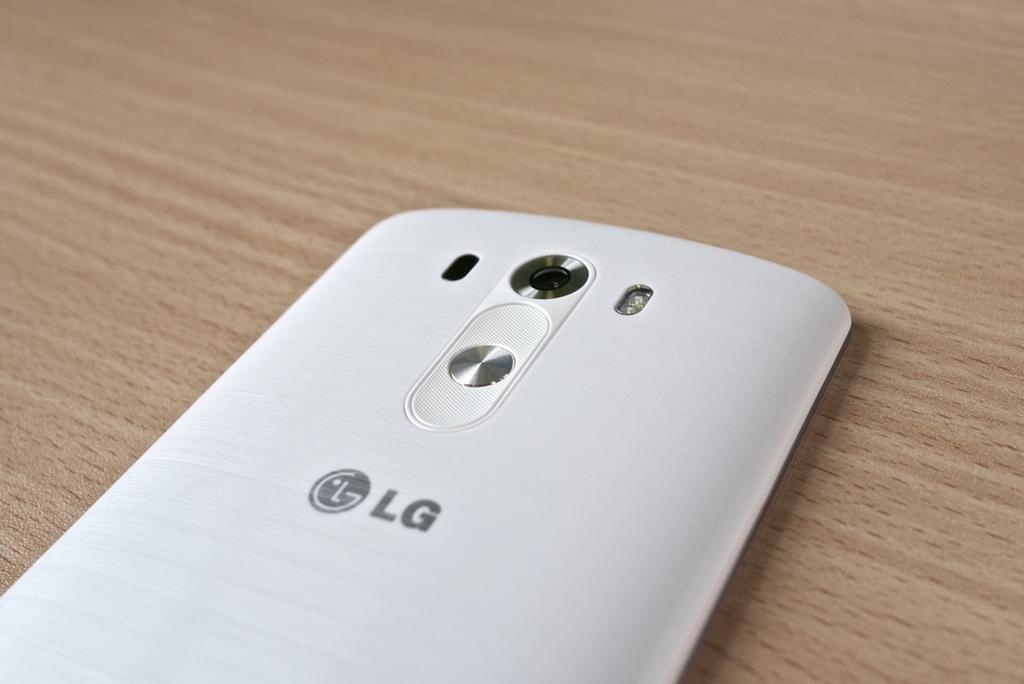What brand is this smartphone?
Provide a succinct answer. Lg. 